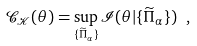Convert formula to latex. <formula><loc_0><loc_0><loc_500><loc_500>\mathcal { C } _ { \mathcal { K } } ( \theta ) = \sup _ { \{ \widetilde { \Pi } _ { \alpha } \} } \mathcal { I } ( \theta | \{ \widetilde { \Pi } _ { \alpha } \} ) \ ,</formula> 